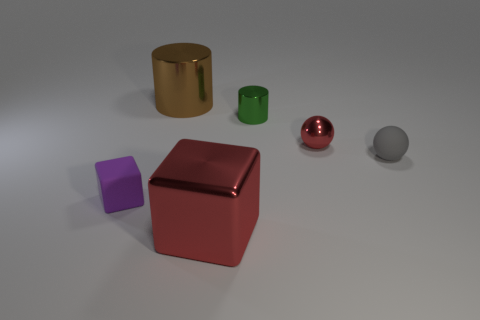What is the shape of the purple thing that is the same size as the green cylinder?
Offer a very short reply. Cube. Are there any small red things of the same shape as the big red object?
Provide a short and direct response. No. There is a tiny thing that is to the left of the thing that is in front of the small purple rubber object; what shape is it?
Offer a terse response. Cube. What is the shape of the large red object?
Your response must be concise. Cube. What is the big object that is in front of the thing that is to the left of the large metallic thing that is behind the small red metallic sphere made of?
Offer a very short reply. Metal. What number of other things are there of the same material as the tiny green cylinder
Give a very brief answer. 3. There is a large shiny object in front of the tiny cylinder; what number of cylinders are to the left of it?
Make the answer very short. 1. What number of cylinders are either purple things or large red things?
Provide a succinct answer. 0. There is a small thing that is both to the left of the tiny red shiny ball and to the right of the tiny purple rubber object; what is its color?
Provide a short and direct response. Green. Is there anything else that has the same color as the tiny metallic ball?
Offer a terse response. Yes. 